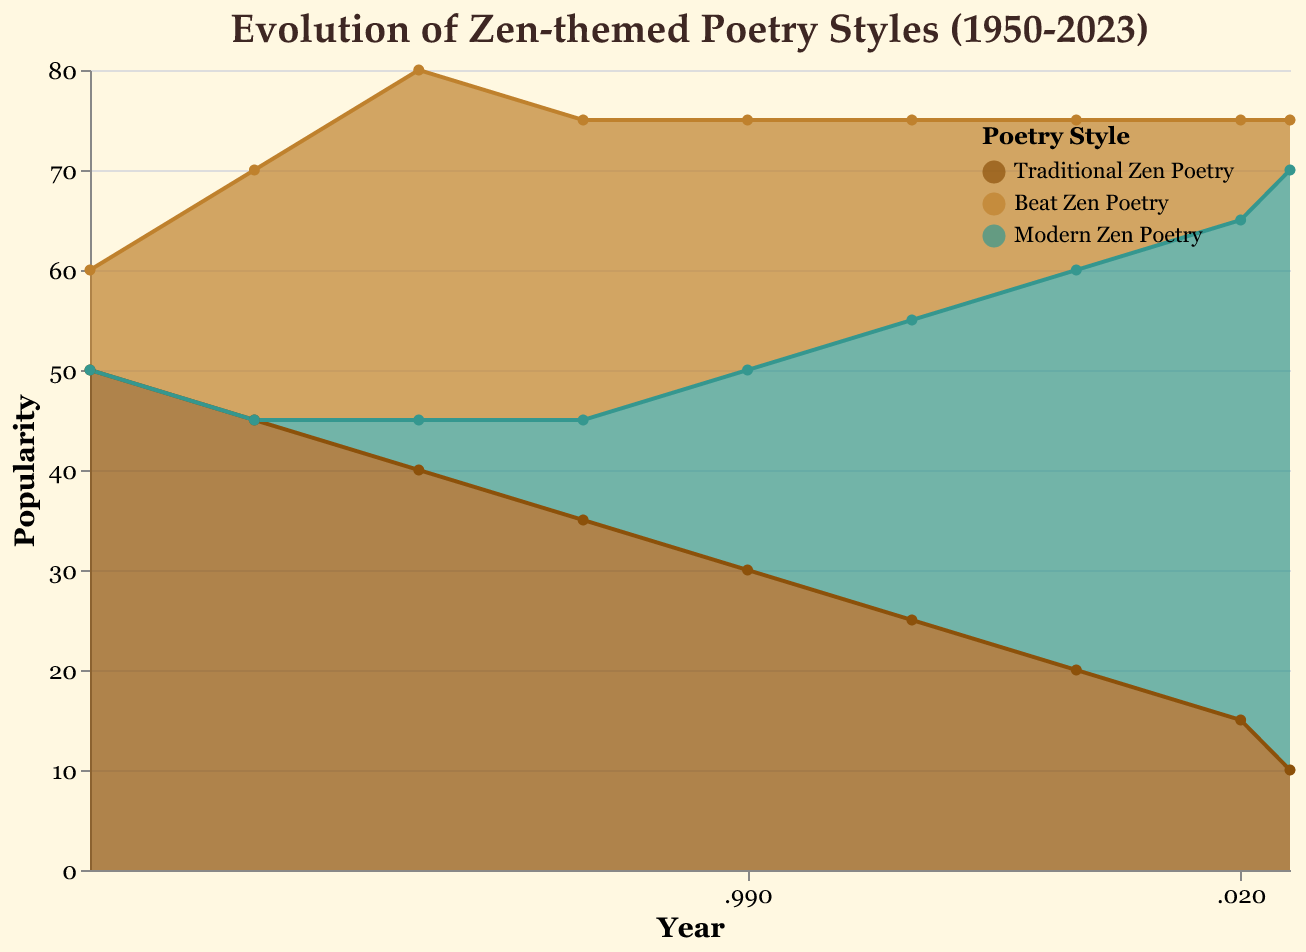What's the title of the chart? The title of the chart is prominently displayed at the top of the figure.
Answer: Evolution of Zen-themed Poetry Styles (1950-2023) What is the overall trend for Traditional Zen Poetry from 1950 to 2023? By observing the lines and filled areas, we can see that the popularity of Traditional Zen Poetry decreases steadily over time.
Answer: It decreases In which year did Modern Zen Poetry first appear in the chart? By looking at the data points for Modern Zen Poetry, we see the first non-zero value occurs in 1970.
Answer: 1970 Compare the popularity of Beat Zen Poetry and Modern Zen Poetry in 1990. Which was more popular? Checking the values for 1990, Beat Zen Poetry stands at 25, whereas Modern Zen Poetry is at 20. Thus, Beat Zen Poetry was more popular in 1990.
Answer: Beat Zen Poetry By how much did the popularity of Traditional Zen Poetry change between 1950 and 2023? The popularity in 1950 is 50, and in 2023 it is 10. The change is calculated by subtracting the latter from the former: 50 - 10.
Answer: 40 What's the total popularity of all Zen Poetry styles combined in 2000? Summing the values of all styles in 2000: 25 (Traditional) + 20 (Beat) + 30 (Modern).
Answer: 75 Which poetry style had the steepest decline in popularity from 1950 to 2023? By observing the decline in values, Traditional Zen Poetry dropped from 50 to 10, which is a decline of 40 units, the steepest among all styles.
Answer: Traditional Zen Poetry What was the most popular form of Zen Poetry in 2023? Checking the values for 2023, Modern Zen Poetry had the highest value at 60, compared to Traditional (10) and Beat (5).
Answer: Modern Zen Poetry What is the trend of Beat Zen Poetry from 1960 to 2010? Analyzing the values for Beat Zen Poetry, from 1960 (25) it rises to 35 in 1970, then decreases steadily down to 15 in 2010.
Answer: Initially increases, then decreases Which year showed equal popularity for Beat Zen Poetry and Modern Zen Poetry? Upon inspection, in 1980, both Beat Zen Poetry (30) and Modern Zen Poetry (10) differ. We see equal values in no other years based on provided data.
Answer: Not applicable 